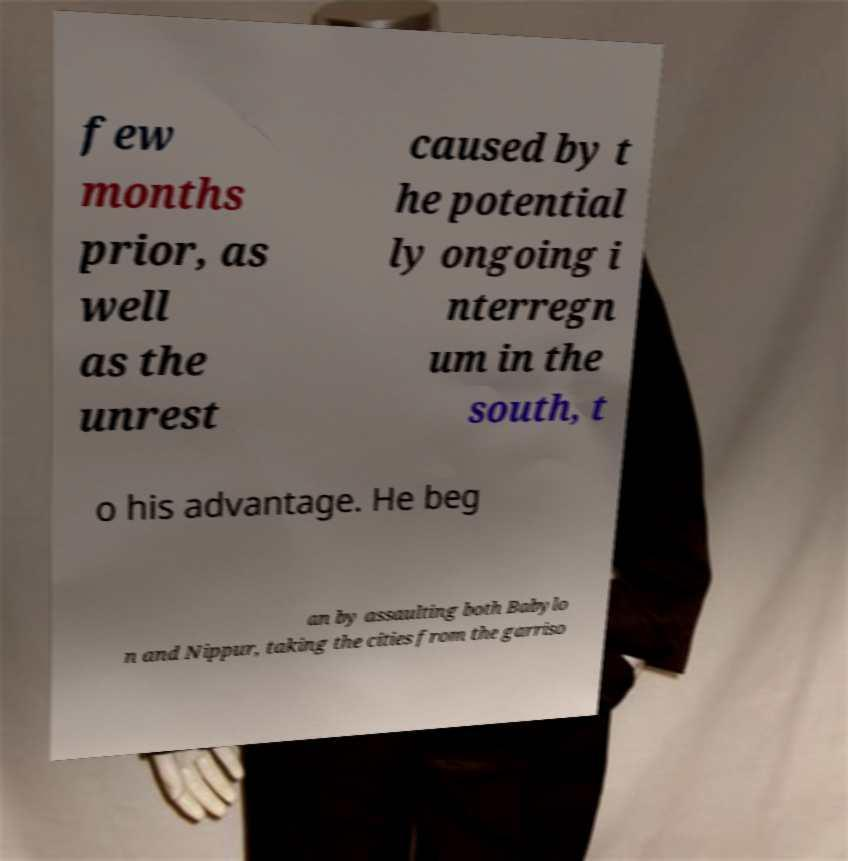Please identify and transcribe the text found in this image. few months prior, as well as the unrest caused by t he potential ly ongoing i nterregn um in the south, t o his advantage. He beg an by assaulting both Babylo n and Nippur, taking the cities from the garriso 